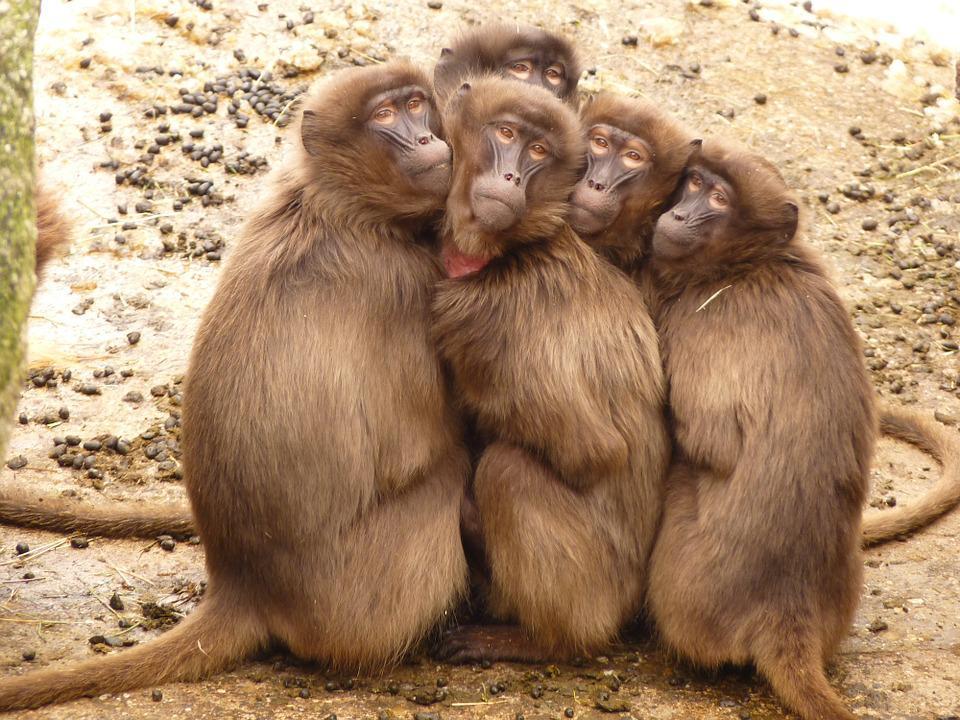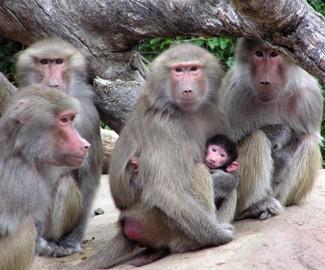The first image is the image on the left, the second image is the image on the right. Evaluate the accuracy of this statement regarding the images: "No monkey is photographed alone.". Is it true? Answer yes or no. Yes. 